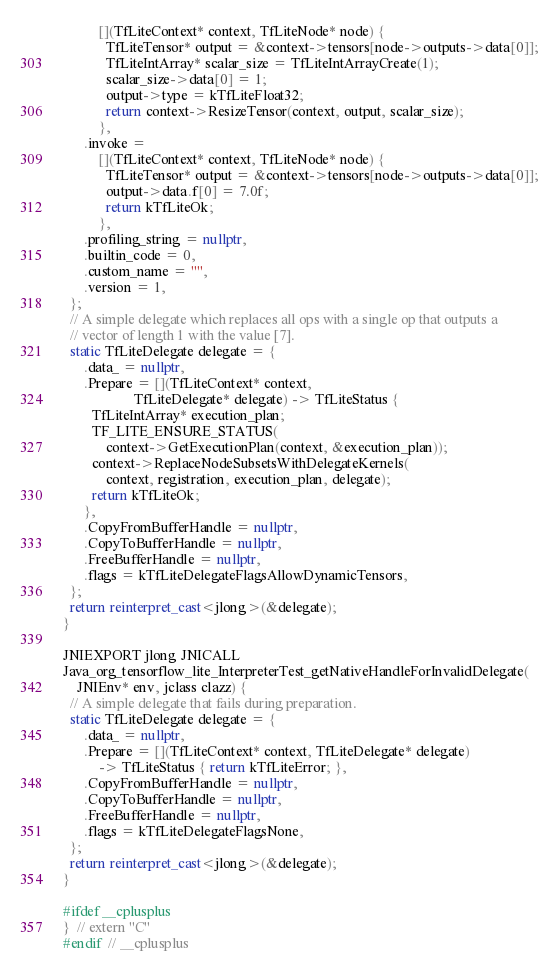<code> <loc_0><loc_0><loc_500><loc_500><_C++_>          [](TfLiteContext* context, TfLiteNode* node) {
            TfLiteTensor* output = &context->tensors[node->outputs->data[0]];
            TfLiteIntArray* scalar_size = TfLiteIntArrayCreate(1);
            scalar_size->data[0] = 1;
            output->type = kTfLiteFloat32;
            return context->ResizeTensor(context, output, scalar_size);
          },
      .invoke =
          [](TfLiteContext* context, TfLiteNode* node) {
            TfLiteTensor* output = &context->tensors[node->outputs->data[0]];
            output->data.f[0] = 7.0f;
            return kTfLiteOk;
          },
      .profiling_string = nullptr,
      .builtin_code = 0,
      .custom_name = "",
      .version = 1,
  };
  // A simple delegate which replaces all ops with a single op that outputs a
  // vector of length 1 with the value [7].
  static TfLiteDelegate delegate = {
      .data_ = nullptr,
      .Prepare = [](TfLiteContext* context,
                    TfLiteDelegate* delegate) -> TfLiteStatus {
        TfLiteIntArray* execution_plan;
        TF_LITE_ENSURE_STATUS(
            context->GetExecutionPlan(context, &execution_plan));
        context->ReplaceNodeSubsetsWithDelegateKernels(
            context, registration, execution_plan, delegate);
        return kTfLiteOk;
      },
      .CopyFromBufferHandle = nullptr,
      .CopyToBufferHandle = nullptr,
      .FreeBufferHandle = nullptr,
      .flags = kTfLiteDelegateFlagsAllowDynamicTensors,
  };
  return reinterpret_cast<jlong>(&delegate);
}

JNIEXPORT jlong JNICALL
Java_org_tensorflow_lite_InterpreterTest_getNativeHandleForInvalidDelegate(
    JNIEnv* env, jclass clazz) {
  // A simple delegate that fails during preparation.
  static TfLiteDelegate delegate = {
      .data_ = nullptr,
      .Prepare = [](TfLiteContext* context, TfLiteDelegate* delegate)
          -> TfLiteStatus { return kTfLiteError; },
      .CopyFromBufferHandle = nullptr,
      .CopyToBufferHandle = nullptr,
      .FreeBufferHandle = nullptr,
      .flags = kTfLiteDelegateFlagsNone,
  };
  return reinterpret_cast<jlong>(&delegate);
}

#ifdef __cplusplus
}  // extern "C"
#endif  // __cplusplus
</code> 